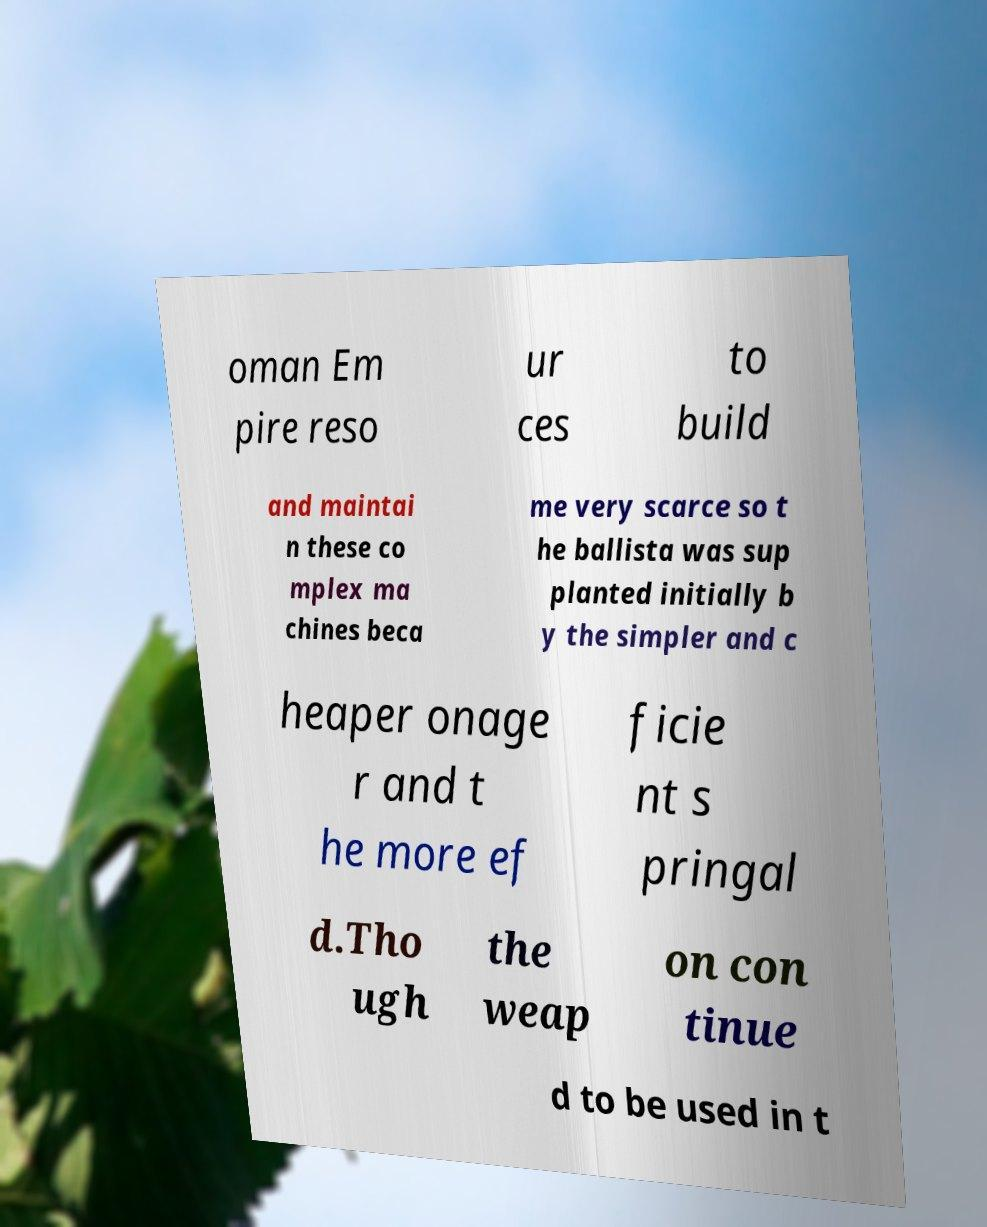There's text embedded in this image that I need extracted. Can you transcribe it verbatim? oman Em pire reso ur ces to build and maintai n these co mplex ma chines beca me very scarce so t he ballista was sup planted initially b y the simpler and c heaper onage r and t he more ef ficie nt s pringal d.Tho ugh the weap on con tinue d to be used in t 